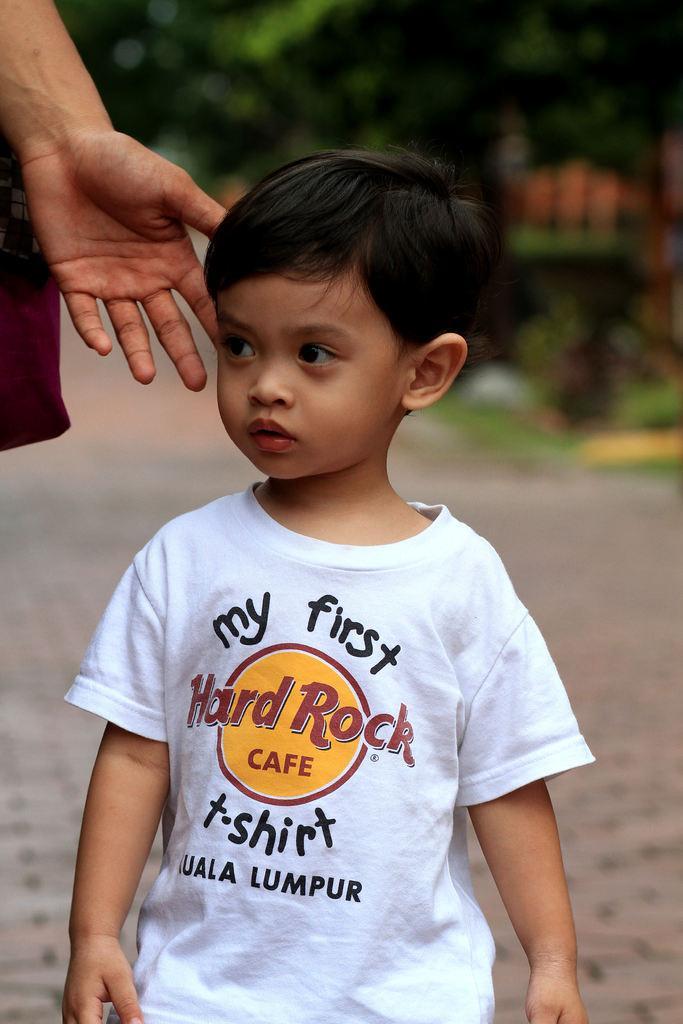Could you give a brief overview of what you see in this image? In the image we can see a boy standing and wearing clothes. On the left side of the image we can see a truncated image of a person. Here we can see the footpath, trees and the background is blurred. 